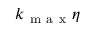Convert formula to latex. <formula><loc_0><loc_0><loc_500><loc_500>k _ { m a x } \eta</formula> 